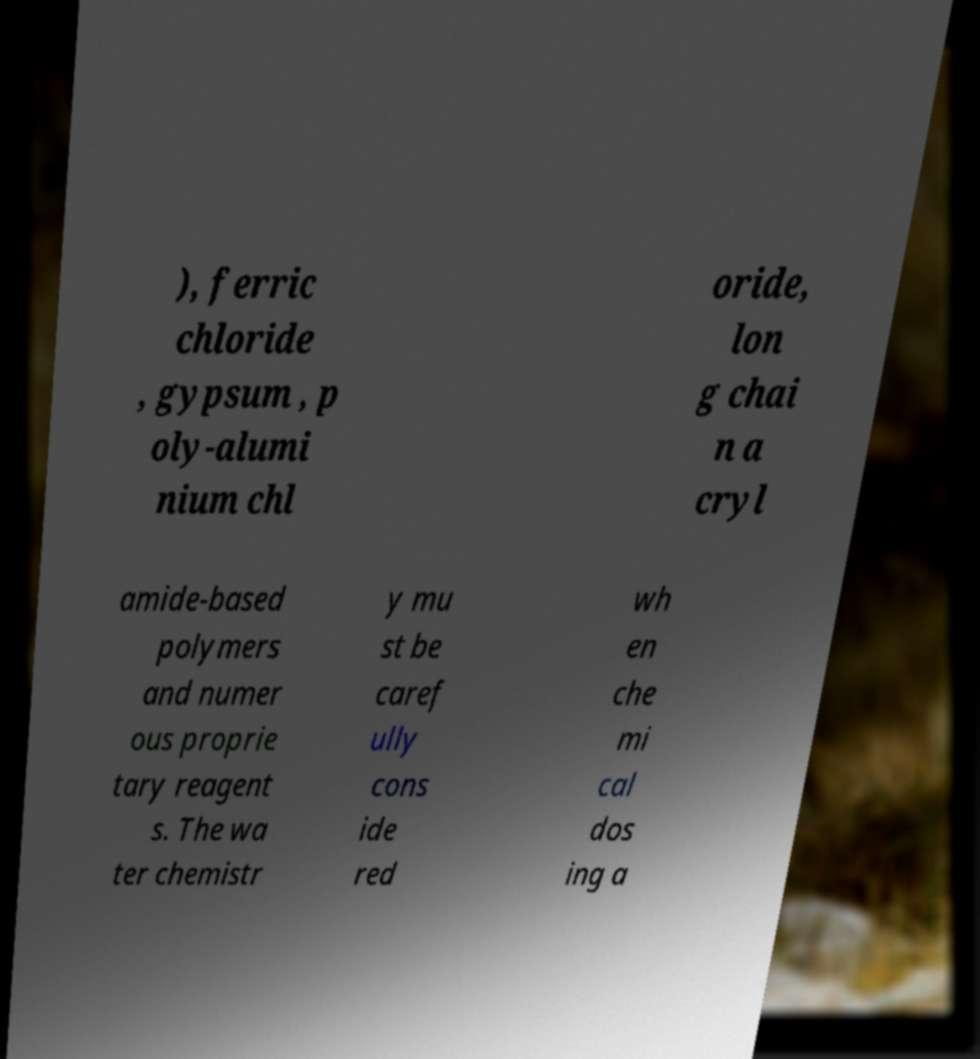Can you accurately transcribe the text from the provided image for me? ), ferric chloride , gypsum , p oly-alumi nium chl oride, lon g chai n a cryl amide-based polymers and numer ous proprie tary reagent s. The wa ter chemistr y mu st be caref ully cons ide red wh en che mi cal dos ing a 